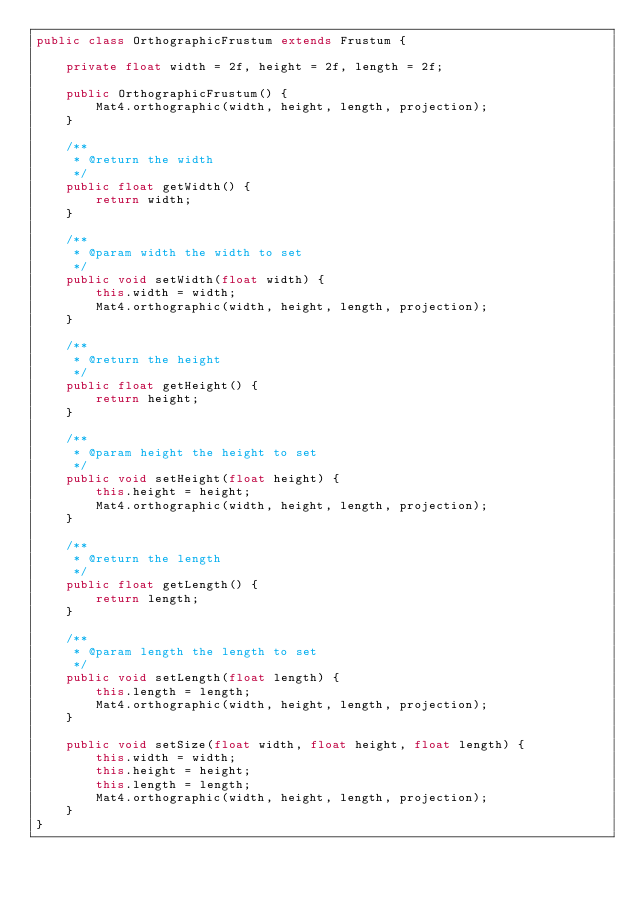Convert code to text. <code><loc_0><loc_0><loc_500><loc_500><_Java_>public class OrthographicFrustum extends Frustum {
	
	private float width = 2f, height = 2f, length = 2f;

	public OrthographicFrustum() {
		Mat4.orthographic(width, height, length, projection);
	}

	/**
	 * @return the width
	 */
	public float getWidth() {
		return width;
	}

	/**
	 * @param width the width to set
	 */
	public void setWidth(float width) {
		this.width = width;
		Mat4.orthographic(width, height, length, projection);
	}

	/**
	 * @return the height
	 */
	public float getHeight() {
		return height;
	}

	/**
	 * @param height the height to set
	 */
	public void setHeight(float height) {
		this.height = height;
		Mat4.orthographic(width, height, length, projection);
	}

	/**
	 * @return the length
	 */
	public float getLength() {
		return length;
	}

	/**
	 * @param length the length to set
	 */
	public void setLength(float length) {
		this.length = length;
		Mat4.orthographic(width, height, length, projection);
	}

	public void setSize(float width, float height, float length) {
		this.width = width;
		this.height = height;
		this.length = length;
		Mat4.orthographic(width, height, length, projection);
	}
}
</code> 